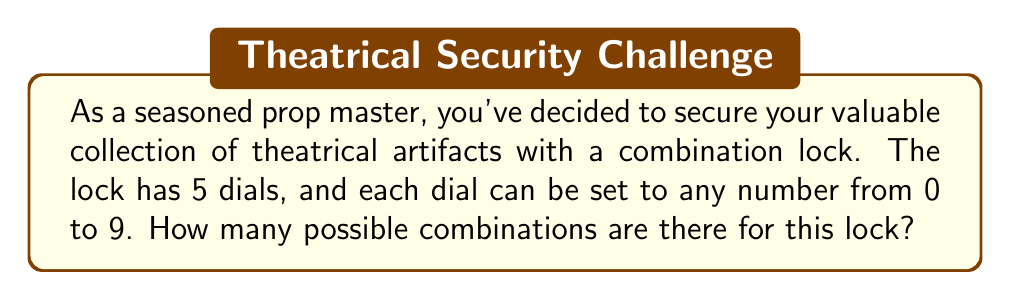Give your solution to this math problem. Let's approach this step-by-step:

1) Each dial can be set to any number from 0 to 9. This means there are 10 possible choices for each dial.

2) We need to determine the number of ways to choose a number for each of the 5 dials.

3) This is a case of the Multiplication Principle in combinatorics. When we have a series of independent choices, the total number of possible outcomes is the product of the number of choices for each decision.

4) In this case, we have:
   - 10 choices for the first dial
   - 10 choices for the second dial
   - 10 choices for the third dial
   - 10 choices for the fourth dial
   - 10 choices for the fifth dial

5) Therefore, the total number of possible combinations is:

   $$ 10 \times 10 \times 10 \times 10 \times 10 = 10^5 $$

6) We can calculate this:

   $$ 10^5 = 100,000 $$

Thus, there are 100,000 possible combinations for the lock.
Answer: 100,000 